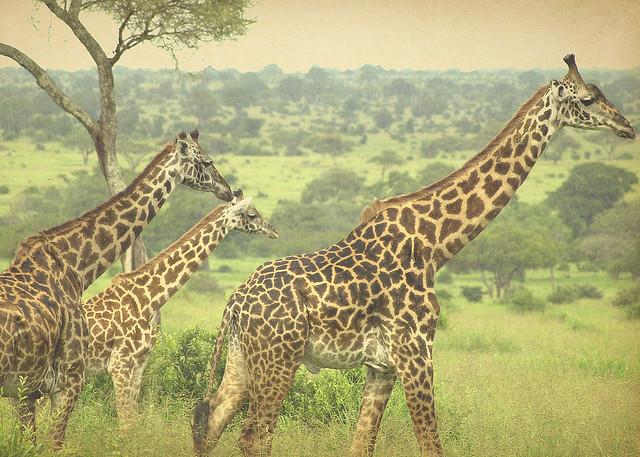Are the animals in the wild or in a zoo?
Give a very brief answer. Wild. How many giraffe are walking across the field?
Give a very brief answer. 3. What is in the background of this photo?
Concise answer only. Trees. 